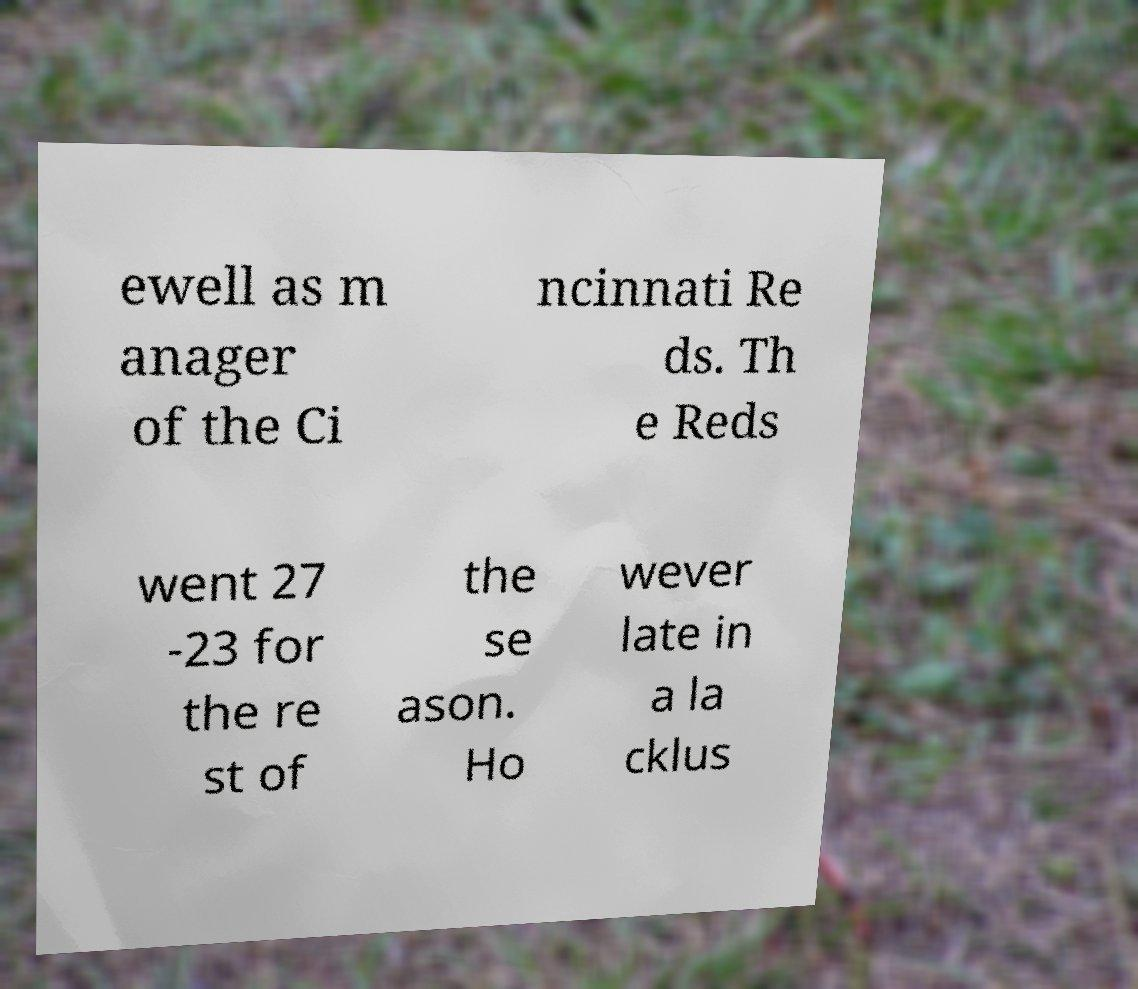What messages or text are displayed in this image? I need them in a readable, typed format. ewell as m anager of the Ci ncinnati Re ds. Th e Reds went 27 -23 for the re st of the se ason. Ho wever late in a la cklus 